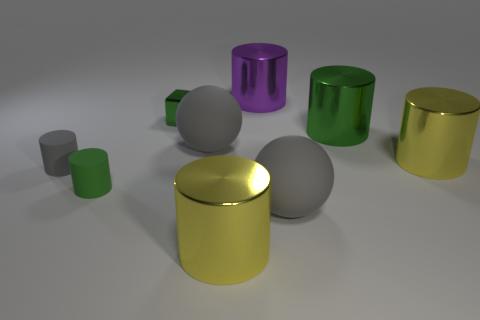Subtract all tiny matte cylinders. How many cylinders are left? 4 Subtract all cyan blocks. How many green cylinders are left? 2 Subtract 3 cylinders. How many cylinders are left? 3 Subtract all yellow cylinders. How many cylinders are left? 4 Subtract all blocks. How many objects are left? 8 Subtract 0 brown balls. How many objects are left? 9 Subtract all gray cylinders. Subtract all purple cubes. How many cylinders are left? 5 Subtract all big blue metallic balls. Subtract all tiny green cylinders. How many objects are left? 8 Add 3 cubes. How many cubes are left? 4 Add 7 tiny cylinders. How many tiny cylinders exist? 9 